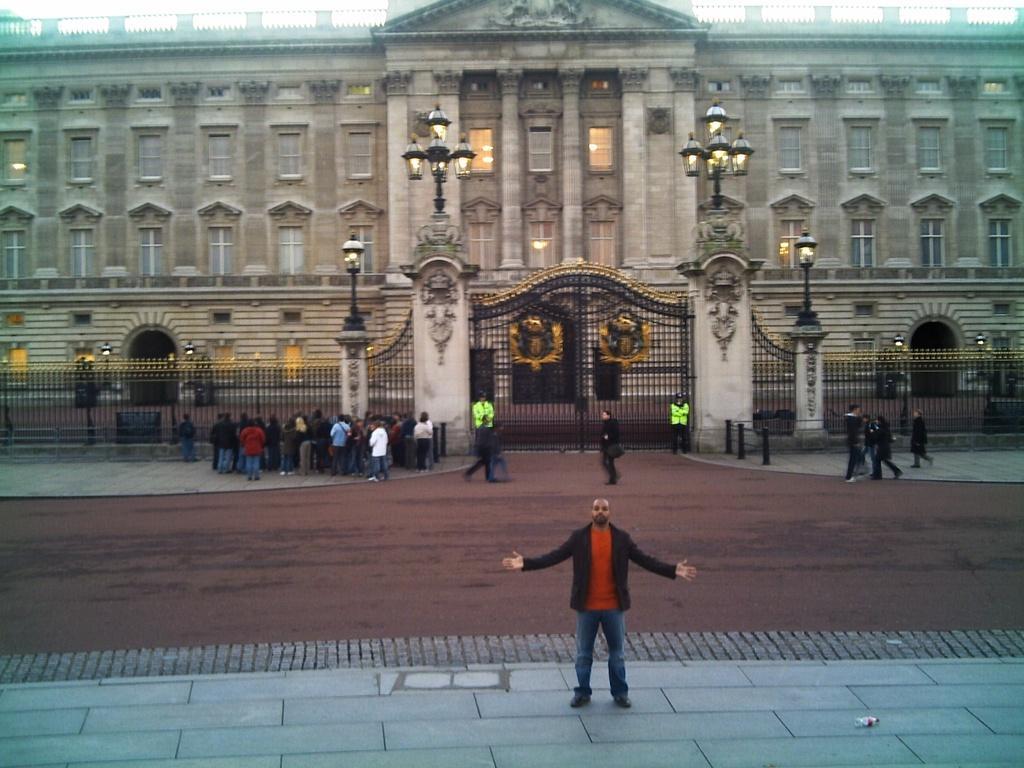Describe this image in one or two sentences. In the image there is a huge building, in front of the building many people were standing and in the front a person is standing on a pavement by stretching his arms. 